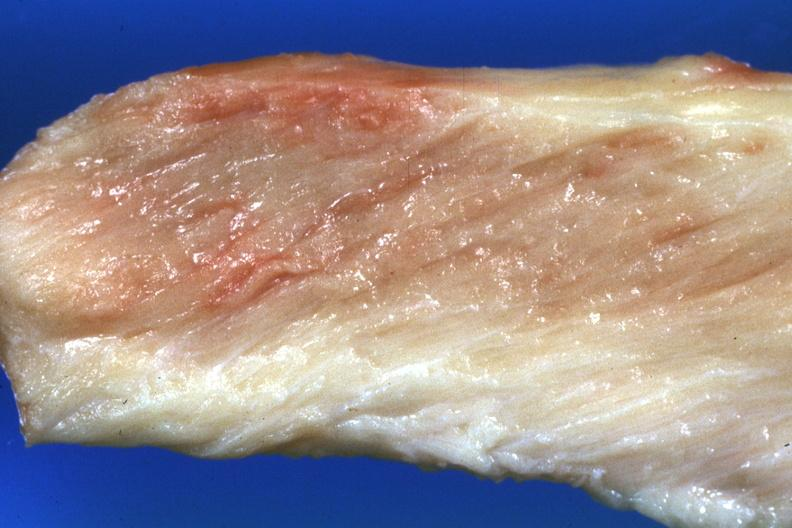does this image show close-up view pale muscle?
Answer the question using a single word or phrase. Yes 